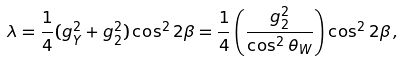<formula> <loc_0><loc_0><loc_500><loc_500>\lambda = \frac { 1 } { 4 } ( g _ { Y } ^ { 2 } + g _ { 2 } ^ { 2 } ) \cos ^ { 2 } 2 \beta = \frac { 1 } { 4 } \left ( \frac { g _ { 2 } ^ { 2 } } { \cos ^ { 2 } \theta _ { W } } \right ) \cos ^ { 2 } 2 \beta \, ,</formula> 